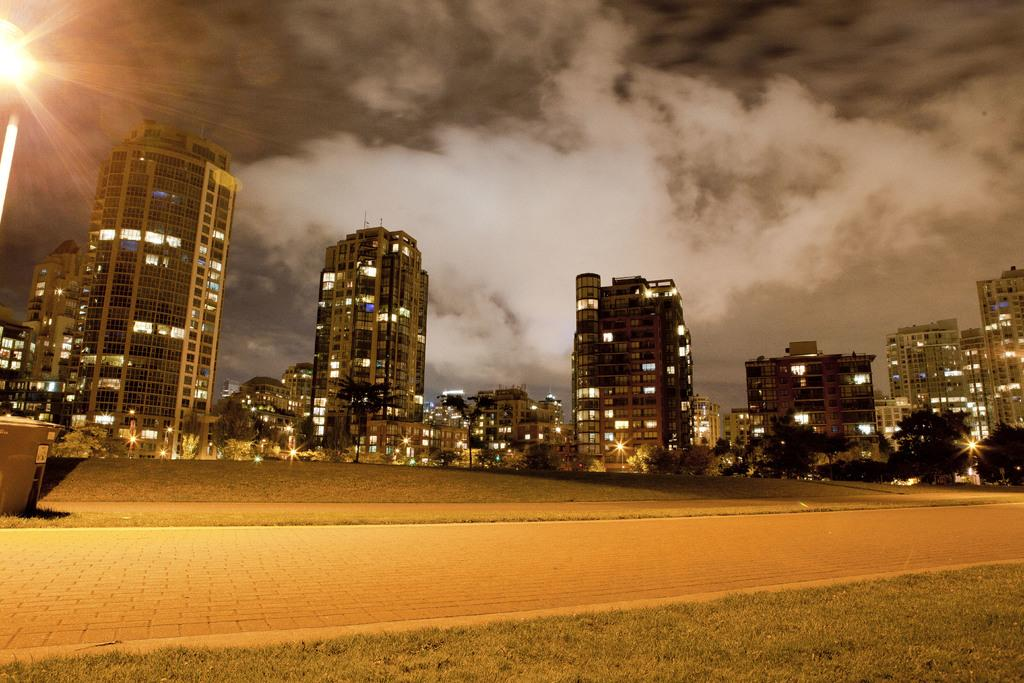What type of structures can be seen in the image? There are many big buildings with lights in the image. What kind of surface is present in the walking area? The walking area has cobbler stones in the image. Is there any greenery visible in the image? Yes, there is a small grass lawn in the image. Where is the recess located in the image? There is no recess present in the image. What is the limit of the grass lawn in the image? The grass lawn does not have a visible limit in the image; it is a small area surrounded by other elements. 